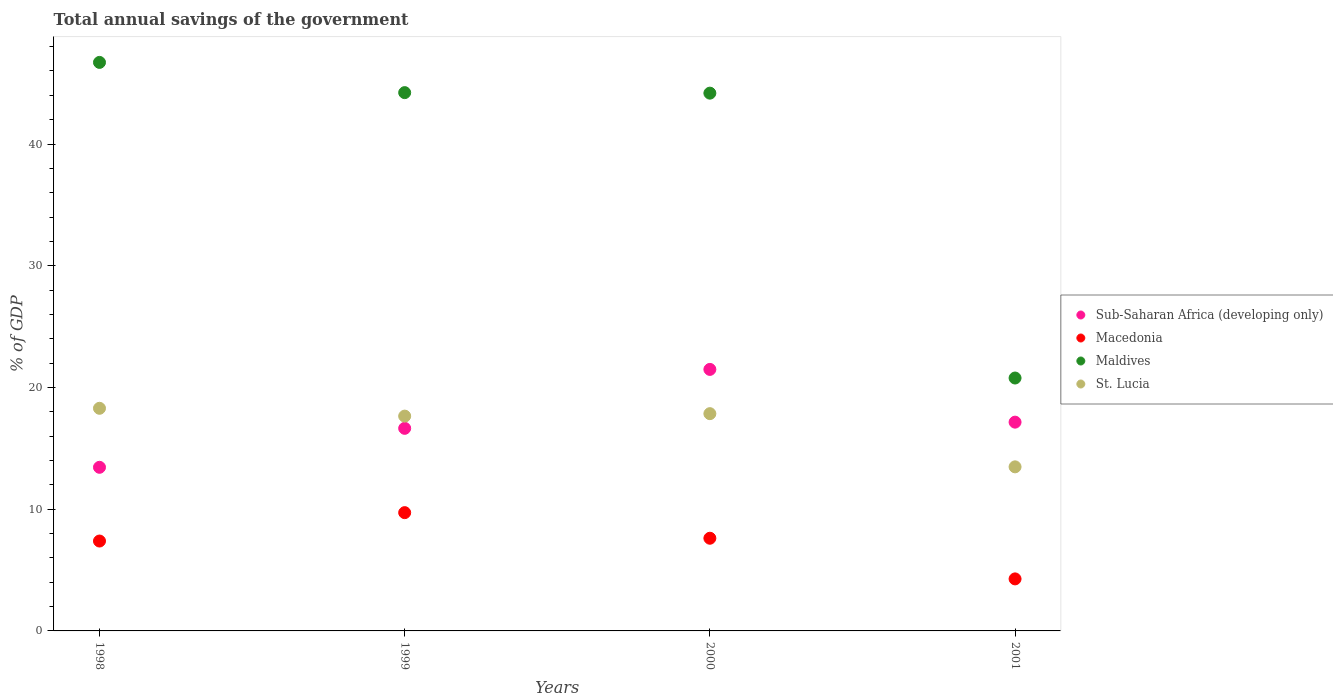How many different coloured dotlines are there?
Your answer should be very brief. 4. Is the number of dotlines equal to the number of legend labels?
Your answer should be compact. Yes. What is the total annual savings of the government in Sub-Saharan Africa (developing only) in 1998?
Provide a succinct answer. 13.44. Across all years, what is the maximum total annual savings of the government in Macedonia?
Your answer should be compact. 9.72. Across all years, what is the minimum total annual savings of the government in Macedonia?
Give a very brief answer. 4.27. In which year was the total annual savings of the government in Macedonia maximum?
Provide a succinct answer. 1999. What is the total total annual savings of the government in Macedonia in the graph?
Keep it short and to the point. 28.99. What is the difference between the total annual savings of the government in Macedonia in 1998 and that in 2001?
Ensure brevity in your answer.  3.11. What is the difference between the total annual savings of the government in Sub-Saharan Africa (developing only) in 1998 and the total annual savings of the government in St. Lucia in 2001?
Offer a very short reply. -0.04. What is the average total annual savings of the government in Sub-Saharan Africa (developing only) per year?
Provide a short and direct response. 17.18. In the year 1998, what is the difference between the total annual savings of the government in Macedonia and total annual savings of the government in St. Lucia?
Your answer should be very brief. -10.91. In how many years, is the total annual savings of the government in Maldives greater than 32 %?
Give a very brief answer. 3. What is the ratio of the total annual savings of the government in Maldives in 2000 to that in 2001?
Offer a very short reply. 2.13. Is the total annual savings of the government in Macedonia in 1999 less than that in 2000?
Offer a very short reply. No. What is the difference between the highest and the second highest total annual savings of the government in Sub-Saharan Africa (developing only)?
Keep it short and to the point. 4.33. What is the difference between the highest and the lowest total annual savings of the government in St. Lucia?
Ensure brevity in your answer.  4.81. In how many years, is the total annual savings of the government in Sub-Saharan Africa (developing only) greater than the average total annual savings of the government in Sub-Saharan Africa (developing only) taken over all years?
Keep it short and to the point. 1. Does the total annual savings of the government in Sub-Saharan Africa (developing only) monotonically increase over the years?
Offer a very short reply. No. Is the total annual savings of the government in Maldives strictly less than the total annual savings of the government in Macedonia over the years?
Your response must be concise. No. How many dotlines are there?
Your answer should be very brief. 4. Are the values on the major ticks of Y-axis written in scientific E-notation?
Your answer should be compact. No. Does the graph contain grids?
Give a very brief answer. No. Where does the legend appear in the graph?
Your answer should be compact. Center right. How many legend labels are there?
Provide a succinct answer. 4. How are the legend labels stacked?
Give a very brief answer. Vertical. What is the title of the graph?
Offer a terse response. Total annual savings of the government. What is the label or title of the Y-axis?
Your answer should be compact. % of GDP. What is the % of GDP of Sub-Saharan Africa (developing only) in 1998?
Give a very brief answer. 13.44. What is the % of GDP in Macedonia in 1998?
Provide a short and direct response. 7.38. What is the % of GDP in Maldives in 1998?
Offer a terse response. 46.7. What is the % of GDP in St. Lucia in 1998?
Offer a terse response. 18.29. What is the % of GDP in Sub-Saharan Africa (developing only) in 1999?
Provide a succinct answer. 16.64. What is the % of GDP of Macedonia in 1999?
Provide a short and direct response. 9.72. What is the % of GDP in Maldives in 1999?
Provide a short and direct response. 44.22. What is the % of GDP of St. Lucia in 1999?
Provide a succinct answer. 17.65. What is the % of GDP of Sub-Saharan Africa (developing only) in 2000?
Offer a terse response. 21.48. What is the % of GDP of Macedonia in 2000?
Provide a succinct answer. 7.61. What is the % of GDP in Maldives in 2000?
Offer a terse response. 44.18. What is the % of GDP of St. Lucia in 2000?
Provide a short and direct response. 17.85. What is the % of GDP of Sub-Saharan Africa (developing only) in 2001?
Provide a short and direct response. 17.15. What is the % of GDP of Macedonia in 2001?
Provide a succinct answer. 4.27. What is the % of GDP in Maldives in 2001?
Provide a short and direct response. 20.78. What is the % of GDP in St. Lucia in 2001?
Give a very brief answer. 13.48. Across all years, what is the maximum % of GDP in Sub-Saharan Africa (developing only)?
Offer a terse response. 21.48. Across all years, what is the maximum % of GDP of Macedonia?
Keep it short and to the point. 9.72. Across all years, what is the maximum % of GDP in Maldives?
Provide a short and direct response. 46.7. Across all years, what is the maximum % of GDP in St. Lucia?
Your answer should be very brief. 18.29. Across all years, what is the minimum % of GDP in Sub-Saharan Africa (developing only)?
Your response must be concise. 13.44. Across all years, what is the minimum % of GDP in Macedonia?
Your response must be concise. 4.27. Across all years, what is the minimum % of GDP of Maldives?
Offer a very short reply. 20.78. Across all years, what is the minimum % of GDP in St. Lucia?
Offer a very short reply. 13.48. What is the total % of GDP in Sub-Saharan Africa (developing only) in the graph?
Provide a short and direct response. 68.72. What is the total % of GDP in Macedonia in the graph?
Give a very brief answer. 28.99. What is the total % of GDP in Maldives in the graph?
Your answer should be compact. 155.88. What is the total % of GDP in St. Lucia in the graph?
Offer a terse response. 67.26. What is the difference between the % of GDP in Sub-Saharan Africa (developing only) in 1998 and that in 1999?
Keep it short and to the point. -3.2. What is the difference between the % of GDP of Macedonia in 1998 and that in 1999?
Your response must be concise. -2.33. What is the difference between the % of GDP in Maldives in 1998 and that in 1999?
Your answer should be compact. 2.48. What is the difference between the % of GDP in St. Lucia in 1998 and that in 1999?
Your answer should be very brief. 0.64. What is the difference between the % of GDP of Sub-Saharan Africa (developing only) in 1998 and that in 2000?
Give a very brief answer. -8.04. What is the difference between the % of GDP in Macedonia in 1998 and that in 2000?
Ensure brevity in your answer.  -0.23. What is the difference between the % of GDP of Maldives in 1998 and that in 2000?
Provide a short and direct response. 2.53. What is the difference between the % of GDP in St. Lucia in 1998 and that in 2000?
Make the answer very short. 0.44. What is the difference between the % of GDP in Sub-Saharan Africa (developing only) in 1998 and that in 2001?
Your response must be concise. -3.71. What is the difference between the % of GDP of Macedonia in 1998 and that in 2001?
Offer a very short reply. 3.11. What is the difference between the % of GDP of Maldives in 1998 and that in 2001?
Your answer should be very brief. 25.93. What is the difference between the % of GDP of St. Lucia in 1998 and that in 2001?
Keep it short and to the point. 4.81. What is the difference between the % of GDP in Sub-Saharan Africa (developing only) in 1999 and that in 2000?
Offer a terse response. -4.84. What is the difference between the % of GDP of Macedonia in 1999 and that in 2000?
Make the answer very short. 2.1. What is the difference between the % of GDP of Maldives in 1999 and that in 2000?
Offer a terse response. 0.04. What is the difference between the % of GDP of St. Lucia in 1999 and that in 2000?
Provide a short and direct response. -0.2. What is the difference between the % of GDP in Sub-Saharan Africa (developing only) in 1999 and that in 2001?
Your answer should be compact. -0.51. What is the difference between the % of GDP of Macedonia in 1999 and that in 2001?
Your answer should be very brief. 5.44. What is the difference between the % of GDP in Maldives in 1999 and that in 2001?
Provide a short and direct response. 23.44. What is the difference between the % of GDP of St. Lucia in 1999 and that in 2001?
Your response must be concise. 4.17. What is the difference between the % of GDP in Sub-Saharan Africa (developing only) in 2000 and that in 2001?
Ensure brevity in your answer.  4.33. What is the difference between the % of GDP in Macedonia in 2000 and that in 2001?
Ensure brevity in your answer.  3.34. What is the difference between the % of GDP of Maldives in 2000 and that in 2001?
Your answer should be compact. 23.4. What is the difference between the % of GDP of St. Lucia in 2000 and that in 2001?
Provide a succinct answer. 4.37. What is the difference between the % of GDP of Sub-Saharan Africa (developing only) in 1998 and the % of GDP of Macedonia in 1999?
Offer a very short reply. 3.73. What is the difference between the % of GDP in Sub-Saharan Africa (developing only) in 1998 and the % of GDP in Maldives in 1999?
Your response must be concise. -30.78. What is the difference between the % of GDP of Sub-Saharan Africa (developing only) in 1998 and the % of GDP of St. Lucia in 1999?
Keep it short and to the point. -4.2. What is the difference between the % of GDP of Macedonia in 1998 and the % of GDP of Maldives in 1999?
Offer a very short reply. -36.84. What is the difference between the % of GDP of Macedonia in 1998 and the % of GDP of St. Lucia in 1999?
Your answer should be compact. -10.26. What is the difference between the % of GDP in Maldives in 1998 and the % of GDP in St. Lucia in 1999?
Keep it short and to the point. 29.06. What is the difference between the % of GDP of Sub-Saharan Africa (developing only) in 1998 and the % of GDP of Macedonia in 2000?
Keep it short and to the point. 5.83. What is the difference between the % of GDP in Sub-Saharan Africa (developing only) in 1998 and the % of GDP in Maldives in 2000?
Your answer should be very brief. -30.74. What is the difference between the % of GDP in Sub-Saharan Africa (developing only) in 1998 and the % of GDP in St. Lucia in 2000?
Give a very brief answer. -4.41. What is the difference between the % of GDP in Macedonia in 1998 and the % of GDP in Maldives in 2000?
Your answer should be compact. -36.79. What is the difference between the % of GDP in Macedonia in 1998 and the % of GDP in St. Lucia in 2000?
Your answer should be very brief. -10.46. What is the difference between the % of GDP of Maldives in 1998 and the % of GDP of St. Lucia in 2000?
Give a very brief answer. 28.86. What is the difference between the % of GDP of Sub-Saharan Africa (developing only) in 1998 and the % of GDP of Macedonia in 2001?
Your answer should be compact. 9.17. What is the difference between the % of GDP in Sub-Saharan Africa (developing only) in 1998 and the % of GDP in Maldives in 2001?
Your response must be concise. -7.33. What is the difference between the % of GDP in Sub-Saharan Africa (developing only) in 1998 and the % of GDP in St. Lucia in 2001?
Ensure brevity in your answer.  -0.04. What is the difference between the % of GDP of Macedonia in 1998 and the % of GDP of Maldives in 2001?
Provide a short and direct response. -13.39. What is the difference between the % of GDP of Macedonia in 1998 and the % of GDP of St. Lucia in 2001?
Give a very brief answer. -6.09. What is the difference between the % of GDP of Maldives in 1998 and the % of GDP of St. Lucia in 2001?
Keep it short and to the point. 33.23. What is the difference between the % of GDP of Sub-Saharan Africa (developing only) in 1999 and the % of GDP of Macedonia in 2000?
Ensure brevity in your answer.  9.03. What is the difference between the % of GDP in Sub-Saharan Africa (developing only) in 1999 and the % of GDP in Maldives in 2000?
Your answer should be compact. -27.54. What is the difference between the % of GDP in Sub-Saharan Africa (developing only) in 1999 and the % of GDP in St. Lucia in 2000?
Offer a very short reply. -1.21. What is the difference between the % of GDP in Macedonia in 1999 and the % of GDP in Maldives in 2000?
Offer a terse response. -34.46. What is the difference between the % of GDP of Macedonia in 1999 and the % of GDP of St. Lucia in 2000?
Ensure brevity in your answer.  -8.13. What is the difference between the % of GDP in Maldives in 1999 and the % of GDP in St. Lucia in 2000?
Provide a succinct answer. 26.37. What is the difference between the % of GDP in Sub-Saharan Africa (developing only) in 1999 and the % of GDP in Macedonia in 2001?
Keep it short and to the point. 12.37. What is the difference between the % of GDP in Sub-Saharan Africa (developing only) in 1999 and the % of GDP in Maldives in 2001?
Offer a terse response. -4.13. What is the difference between the % of GDP of Sub-Saharan Africa (developing only) in 1999 and the % of GDP of St. Lucia in 2001?
Your response must be concise. 3.16. What is the difference between the % of GDP of Macedonia in 1999 and the % of GDP of Maldives in 2001?
Offer a very short reply. -11.06. What is the difference between the % of GDP in Macedonia in 1999 and the % of GDP in St. Lucia in 2001?
Provide a succinct answer. -3.76. What is the difference between the % of GDP in Maldives in 1999 and the % of GDP in St. Lucia in 2001?
Your response must be concise. 30.74. What is the difference between the % of GDP of Sub-Saharan Africa (developing only) in 2000 and the % of GDP of Macedonia in 2001?
Offer a terse response. 17.21. What is the difference between the % of GDP in Sub-Saharan Africa (developing only) in 2000 and the % of GDP in Maldives in 2001?
Ensure brevity in your answer.  0.71. What is the difference between the % of GDP of Sub-Saharan Africa (developing only) in 2000 and the % of GDP of St. Lucia in 2001?
Your answer should be very brief. 8. What is the difference between the % of GDP of Macedonia in 2000 and the % of GDP of Maldives in 2001?
Your answer should be very brief. -13.16. What is the difference between the % of GDP of Macedonia in 2000 and the % of GDP of St. Lucia in 2001?
Give a very brief answer. -5.87. What is the difference between the % of GDP of Maldives in 2000 and the % of GDP of St. Lucia in 2001?
Provide a succinct answer. 30.7. What is the average % of GDP in Sub-Saharan Africa (developing only) per year?
Provide a succinct answer. 17.18. What is the average % of GDP in Macedonia per year?
Keep it short and to the point. 7.25. What is the average % of GDP in Maldives per year?
Keep it short and to the point. 38.97. What is the average % of GDP of St. Lucia per year?
Your response must be concise. 16.82. In the year 1998, what is the difference between the % of GDP in Sub-Saharan Africa (developing only) and % of GDP in Macedonia?
Offer a terse response. 6.06. In the year 1998, what is the difference between the % of GDP of Sub-Saharan Africa (developing only) and % of GDP of Maldives?
Your answer should be very brief. -33.26. In the year 1998, what is the difference between the % of GDP of Sub-Saharan Africa (developing only) and % of GDP of St. Lucia?
Your response must be concise. -4.85. In the year 1998, what is the difference between the % of GDP in Macedonia and % of GDP in Maldives?
Ensure brevity in your answer.  -39.32. In the year 1998, what is the difference between the % of GDP of Macedonia and % of GDP of St. Lucia?
Provide a succinct answer. -10.91. In the year 1998, what is the difference between the % of GDP of Maldives and % of GDP of St. Lucia?
Provide a succinct answer. 28.41. In the year 1999, what is the difference between the % of GDP of Sub-Saharan Africa (developing only) and % of GDP of Macedonia?
Provide a short and direct response. 6.93. In the year 1999, what is the difference between the % of GDP in Sub-Saharan Africa (developing only) and % of GDP in Maldives?
Offer a terse response. -27.58. In the year 1999, what is the difference between the % of GDP of Sub-Saharan Africa (developing only) and % of GDP of St. Lucia?
Provide a short and direct response. -1. In the year 1999, what is the difference between the % of GDP of Macedonia and % of GDP of Maldives?
Offer a terse response. -34.5. In the year 1999, what is the difference between the % of GDP of Macedonia and % of GDP of St. Lucia?
Make the answer very short. -7.93. In the year 1999, what is the difference between the % of GDP in Maldives and % of GDP in St. Lucia?
Offer a terse response. 26.57. In the year 2000, what is the difference between the % of GDP of Sub-Saharan Africa (developing only) and % of GDP of Macedonia?
Offer a terse response. 13.87. In the year 2000, what is the difference between the % of GDP of Sub-Saharan Africa (developing only) and % of GDP of Maldives?
Give a very brief answer. -22.69. In the year 2000, what is the difference between the % of GDP of Sub-Saharan Africa (developing only) and % of GDP of St. Lucia?
Offer a very short reply. 3.63. In the year 2000, what is the difference between the % of GDP of Macedonia and % of GDP of Maldives?
Provide a succinct answer. -36.56. In the year 2000, what is the difference between the % of GDP of Macedonia and % of GDP of St. Lucia?
Make the answer very short. -10.23. In the year 2000, what is the difference between the % of GDP of Maldives and % of GDP of St. Lucia?
Your answer should be compact. 26.33. In the year 2001, what is the difference between the % of GDP of Sub-Saharan Africa (developing only) and % of GDP of Macedonia?
Your answer should be very brief. 12.88. In the year 2001, what is the difference between the % of GDP of Sub-Saharan Africa (developing only) and % of GDP of Maldives?
Your response must be concise. -3.63. In the year 2001, what is the difference between the % of GDP in Sub-Saharan Africa (developing only) and % of GDP in St. Lucia?
Offer a terse response. 3.67. In the year 2001, what is the difference between the % of GDP in Macedonia and % of GDP in Maldives?
Your answer should be compact. -16.5. In the year 2001, what is the difference between the % of GDP of Macedonia and % of GDP of St. Lucia?
Offer a very short reply. -9.2. In the year 2001, what is the difference between the % of GDP in Maldives and % of GDP in St. Lucia?
Offer a very short reply. 7.3. What is the ratio of the % of GDP of Sub-Saharan Africa (developing only) in 1998 to that in 1999?
Offer a terse response. 0.81. What is the ratio of the % of GDP in Macedonia in 1998 to that in 1999?
Your answer should be compact. 0.76. What is the ratio of the % of GDP of Maldives in 1998 to that in 1999?
Provide a succinct answer. 1.06. What is the ratio of the % of GDP of St. Lucia in 1998 to that in 1999?
Provide a short and direct response. 1.04. What is the ratio of the % of GDP of Sub-Saharan Africa (developing only) in 1998 to that in 2000?
Make the answer very short. 0.63. What is the ratio of the % of GDP of Macedonia in 1998 to that in 2000?
Provide a succinct answer. 0.97. What is the ratio of the % of GDP of Maldives in 1998 to that in 2000?
Provide a succinct answer. 1.06. What is the ratio of the % of GDP of St. Lucia in 1998 to that in 2000?
Offer a terse response. 1.02. What is the ratio of the % of GDP in Sub-Saharan Africa (developing only) in 1998 to that in 2001?
Keep it short and to the point. 0.78. What is the ratio of the % of GDP of Macedonia in 1998 to that in 2001?
Make the answer very short. 1.73. What is the ratio of the % of GDP in Maldives in 1998 to that in 2001?
Provide a succinct answer. 2.25. What is the ratio of the % of GDP of St. Lucia in 1998 to that in 2001?
Keep it short and to the point. 1.36. What is the ratio of the % of GDP of Sub-Saharan Africa (developing only) in 1999 to that in 2000?
Offer a very short reply. 0.77. What is the ratio of the % of GDP in Macedonia in 1999 to that in 2000?
Provide a succinct answer. 1.28. What is the ratio of the % of GDP in St. Lucia in 1999 to that in 2000?
Make the answer very short. 0.99. What is the ratio of the % of GDP of Sub-Saharan Africa (developing only) in 1999 to that in 2001?
Your answer should be very brief. 0.97. What is the ratio of the % of GDP in Macedonia in 1999 to that in 2001?
Your answer should be compact. 2.27. What is the ratio of the % of GDP of Maldives in 1999 to that in 2001?
Ensure brevity in your answer.  2.13. What is the ratio of the % of GDP of St. Lucia in 1999 to that in 2001?
Give a very brief answer. 1.31. What is the ratio of the % of GDP in Sub-Saharan Africa (developing only) in 2000 to that in 2001?
Make the answer very short. 1.25. What is the ratio of the % of GDP of Macedonia in 2000 to that in 2001?
Ensure brevity in your answer.  1.78. What is the ratio of the % of GDP in Maldives in 2000 to that in 2001?
Offer a very short reply. 2.13. What is the ratio of the % of GDP in St. Lucia in 2000 to that in 2001?
Provide a short and direct response. 1.32. What is the difference between the highest and the second highest % of GDP in Sub-Saharan Africa (developing only)?
Your answer should be compact. 4.33. What is the difference between the highest and the second highest % of GDP in Macedonia?
Your response must be concise. 2.1. What is the difference between the highest and the second highest % of GDP of Maldives?
Your response must be concise. 2.48. What is the difference between the highest and the second highest % of GDP in St. Lucia?
Ensure brevity in your answer.  0.44. What is the difference between the highest and the lowest % of GDP in Sub-Saharan Africa (developing only)?
Your answer should be compact. 8.04. What is the difference between the highest and the lowest % of GDP of Macedonia?
Provide a short and direct response. 5.44. What is the difference between the highest and the lowest % of GDP in Maldives?
Give a very brief answer. 25.93. What is the difference between the highest and the lowest % of GDP of St. Lucia?
Ensure brevity in your answer.  4.81. 